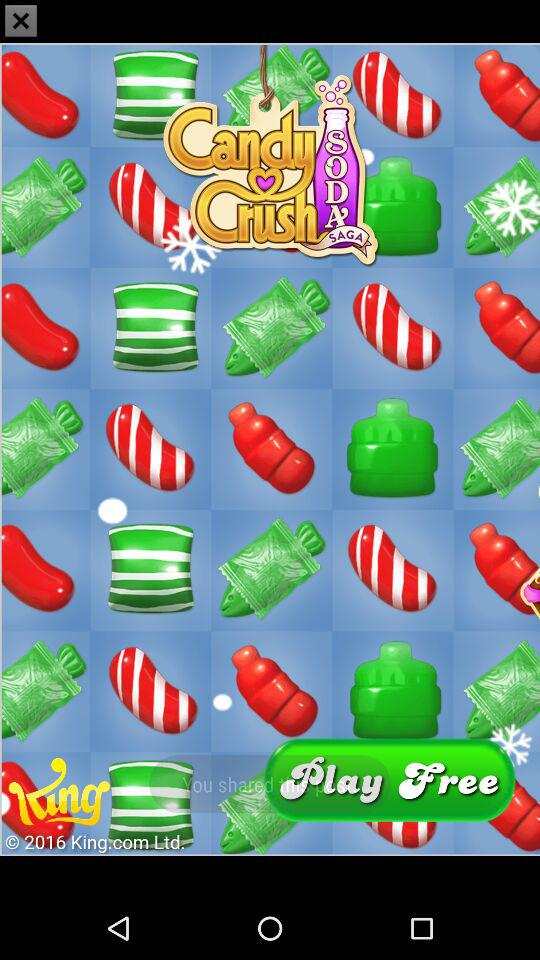What is the application name? The application name is "Candy Crush SODA SAGA". 